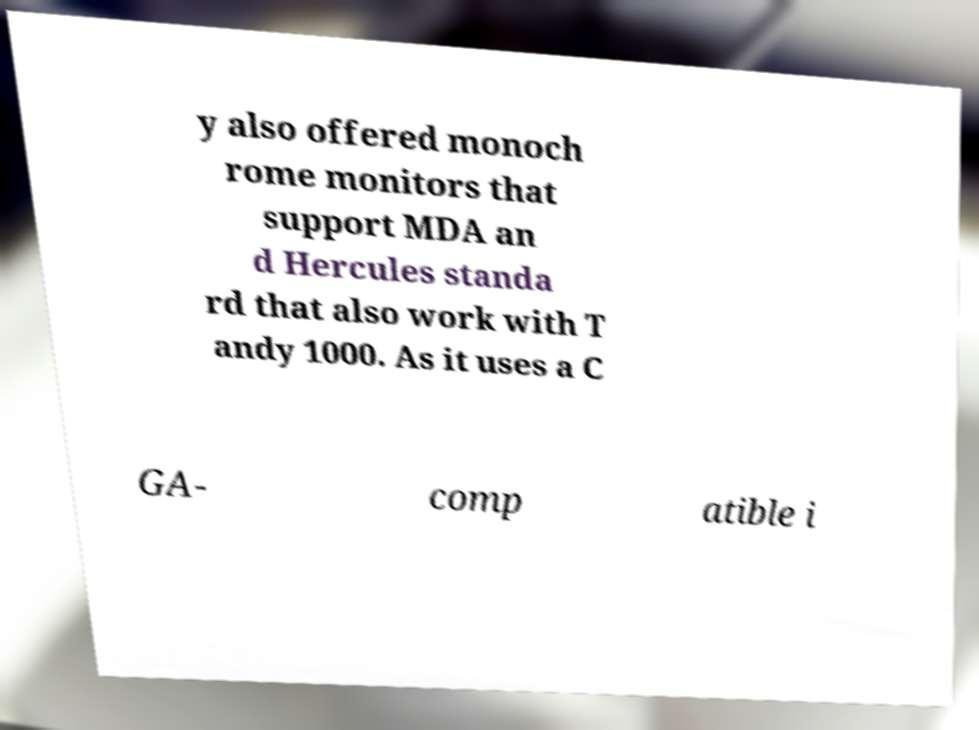What messages or text are displayed in this image? I need them in a readable, typed format. y also offered monoch rome monitors that support MDA an d Hercules standa rd that also work with T andy 1000. As it uses a C GA- comp atible i 